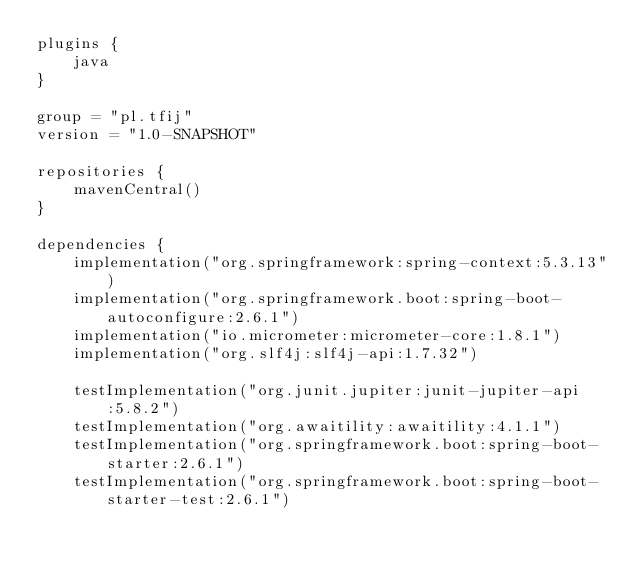<code> <loc_0><loc_0><loc_500><loc_500><_Kotlin_>plugins {
    java
}

group = "pl.tfij"
version = "1.0-SNAPSHOT"

repositories {
    mavenCentral()
}

dependencies {
    implementation("org.springframework:spring-context:5.3.13")
    implementation("org.springframework.boot:spring-boot-autoconfigure:2.6.1")
    implementation("io.micrometer:micrometer-core:1.8.1")
    implementation("org.slf4j:slf4j-api:1.7.32")

    testImplementation("org.junit.jupiter:junit-jupiter-api:5.8.2")
    testImplementation("org.awaitility:awaitility:4.1.1")
    testImplementation("org.springframework.boot:spring-boot-starter:2.6.1")
    testImplementation("org.springframework.boot:spring-boot-starter-test:2.6.1")</code> 